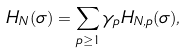Convert formula to latex. <formula><loc_0><loc_0><loc_500><loc_500>H _ { N } ( \sigma ) = \sum _ { p \geq 1 } \gamma _ { p } H _ { N , p } ( \sigma ) ,</formula> 